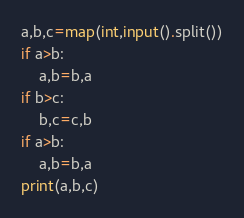Convert code to text. <code><loc_0><loc_0><loc_500><loc_500><_Python_>a,b,c=map(int,input().split())
if a>b:
    a,b=b,a
if b>c:
    b,c=c,b
if a>b:
    a,b=b,a
print(a,b,c)
</code> 